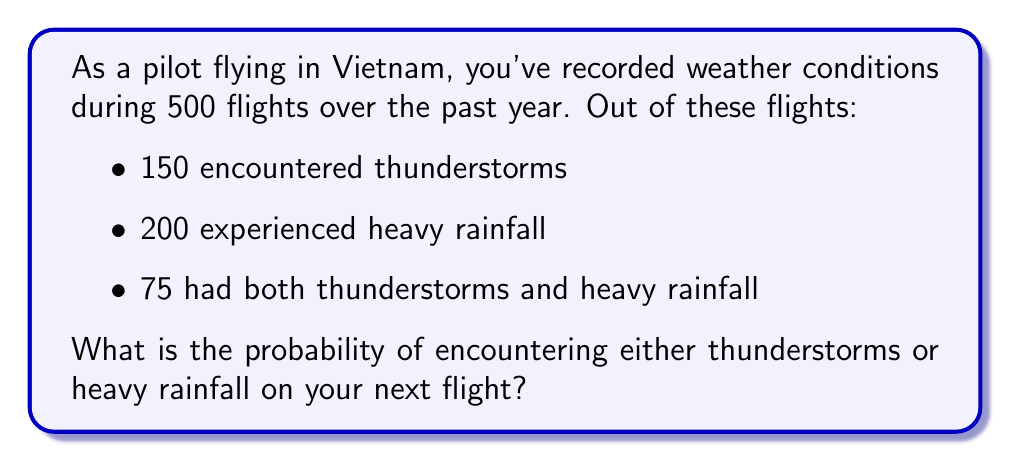Can you solve this math problem? Let's approach this step-by-step using the addition rule of probability:

1) Let A be the event of encountering thunderstorms, and B be the event of experiencing heavy rainfall.

2) We're given:
   P(A) = 150/500 = 0.3
   P(B) = 200/500 = 0.4
   P(A ∩ B) = 75/500 = 0.15

3) We want to find P(A ∪ B), the probability of encountering either thunderstorms or heavy rainfall (or both).

4) The addition rule of probability states:
   $$P(A ∪ B) = P(A) + P(B) - P(A ∩ B)$$

5) Substituting our known values:
   $$P(A ∪ B) = 0.3 + 0.4 - 0.15$$

6) Calculating:
   $$P(A ∪ B) = 0.55$$

Therefore, the probability of encountering either thunderstorms or heavy rainfall on your next flight is 0.55 or 55%.
Answer: 0.55 